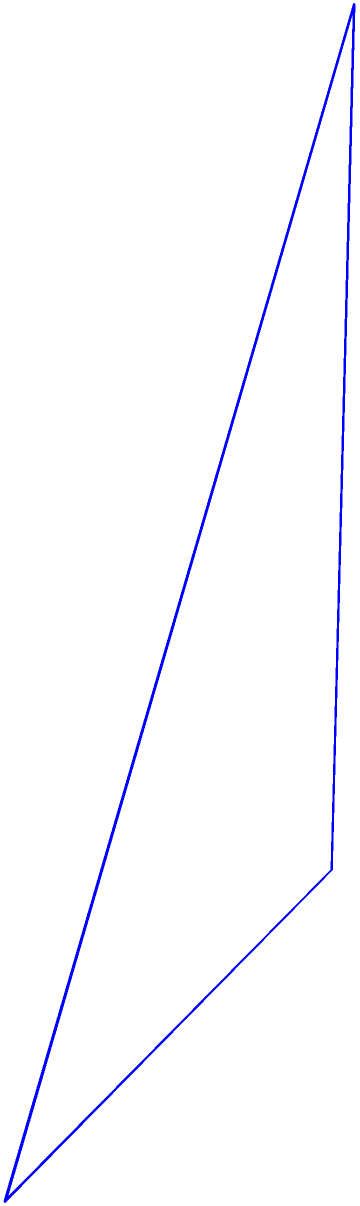As an expert embroiderer working on a period costume, you need to create a cone-shaped headdress. The base of the headdress has a radius of 3 inches, and its height is 4 inches. Calculate the volume of the headdress to determine the amount of fabric needed. Use $\pi = 3.14$ for your calculations. To find the volume of a cone, we use the formula:

$$V = \frac{1}{3}\pi r^2 h$$

Where:
$V$ = volume
$r$ = radius of the base
$h$ = height of the cone

Given:
$r = 3$ inches
$h = 4$ inches
$\pi = 3.14$

Let's substitute these values into the formula:

$$V = \frac{1}{3} \times 3.14 \times 3^2 \times 4$$

Now, let's calculate step by step:

1) First, calculate $r^2$:
   $3^2 = 9$

2) Multiply all the numbers:
   $\frac{1}{3} \times 3.14 \times 9 \times 4 = 37.68$

Therefore, the volume of the cone-shaped headdress is 37.68 cubic inches.
Answer: 37.68 cubic inches 